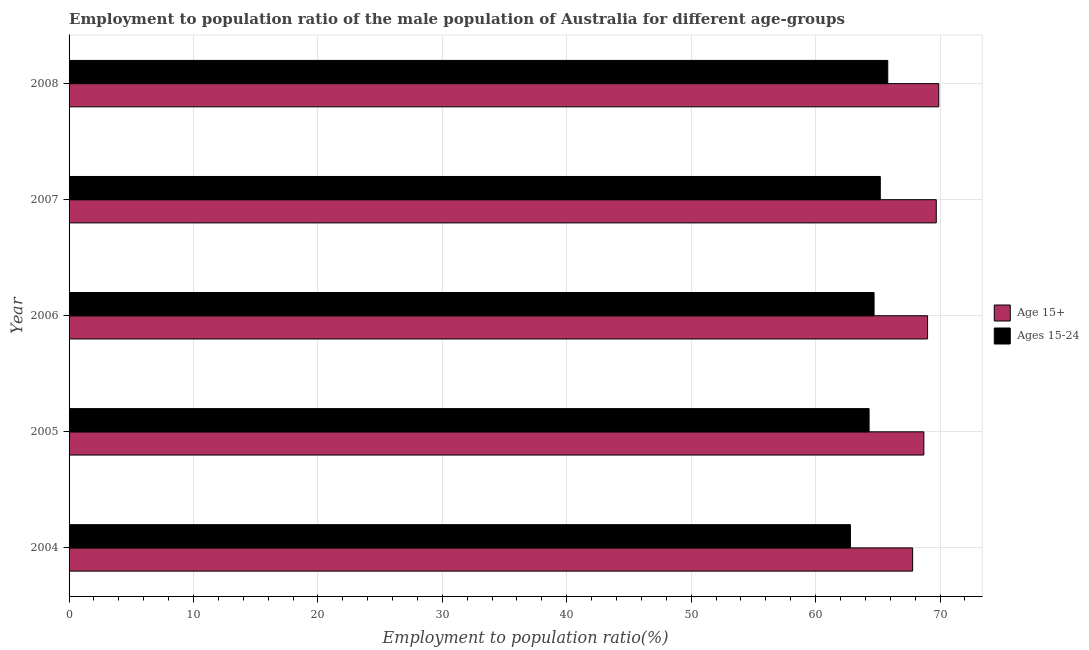Are the number of bars per tick equal to the number of legend labels?
Offer a very short reply. Yes. How many bars are there on the 1st tick from the bottom?
Offer a terse response. 2. What is the label of the 2nd group of bars from the top?
Provide a short and direct response. 2007. What is the employment to population ratio(age 15-24) in 2007?
Offer a very short reply. 65.2. Across all years, what is the maximum employment to population ratio(age 15+)?
Provide a succinct answer. 69.9. Across all years, what is the minimum employment to population ratio(age 15+)?
Offer a terse response. 67.8. In which year was the employment to population ratio(age 15-24) maximum?
Offer a terse response. 2008. In which year was the employment to population ratio(age 15-24) minimum?
Your answer should be compact. 2004. What is the total employment to population ratio(age 15-24) in the graph?
Offer a terse response. 322.8. What is the average employment to population ratio(age 15-24) per year?
Keep it short and to the point. 64.56. What is the ratio of the employment to population ratio(age 15+) in 2004 to that in 2005?
Your answer should be very brief. 0.99. Is the employment to population ratio(age 15+) in 2004 less than that in 2006?
Provide a short and direct response. Yes. Is the difference between the employment to population ratio(age 15-24) in 2004 and 2006 greater than the difference between the employment to population ratio(age 15+) in 2004 and 2006?
Make the answer very short. No. What does the 1st bar from the top in 2005 represents?
Your answer should be very brief. Ages 15-24. What does the 1st bar from the bottom in 2007 represents?
Offer a very short reply. Age 15+. Are all the bars in the graph horizontal?
Your answer should be very brief. Yes. How many years are there in the graph?
Provide a short and direct response. 5. What is the difference between two consecutive major ticks on the X-axis?
Provide a short and direct response. 10. Are the values on the major ticks of X-axis written in scientific E-notation?
Your answer should be compact. No. Does the graph contain any zero values?
Make the answer very short. No. Where does the legend appear in the graph?
Ensure brevity in your answer.  Center right. How many legend labels are there?
Ensure brevity in your answer.  2. How are the legend labels stacked?
Offer a very short reply. Vertical. What is the title of the graph?
Keep it short and to the point. Employment to population ratio of the male population of Australia for different age-groups. What is the Employment to population ratio(%) in Age 15+ in 2004?
Give a very brief answer. 67.8. What is the Employment to population ratio(%) of Ages 15-24 in 2004?
Your response must be concise. 62.8. What is the Employment to population ratio(%) in Age 15+ in 2005?
Ensure brevity in your answer.  68.7. What is the Employment to population ratio(%) of Ages 15-24 in 2005?
Ensure brevity in your answer.  64.3. What is the Employment to population ratio(%) of Age 15+ in 2006?
Your answer should be compact. 69. What is the Employment to population ratio(%) of Ages 15-24 in 2006?
Keep it short and to the point. 64.7. What is the Employment to population ratio(%) in Age 15+ in 2007?
Make the answer very short. 69.7. What is the Employment to population ratio(%) in Ages 15-24 in 2007?
Provide a succinct answer. 65.2. What is the Employment to population ratio(%) of Age 15+ in 2008?
Provide a succinct answer. 69.9. What is the Employment to population ratio(%) of Ages 15-24 in 2008?
Provide a succinct answer. 65.8. Across all years, what is the maximum Employment to population ratio(%) of Age 15+?
Your response must be concise. 69.9. Across all years, what is the maximum Employment to population ratio(%) in Ages 15-24?
Your answer should be very brief. 65.8. Across all years, what is the minimum Employment to population ratio(%) of Age 15+?
Your answer should be very brief. 67.8. Across all years, what is the minimum Employment to population ratio(%) of Ages 15-24?
Provide a succinct answer. 62.8. What is the total Employment to population ratio(%) of Age 15+ in the graph?
Ensure brevity in your answer.  345.1. What is the total Employment to population ratio(%) in Ages 15-24 in the graph?
Give a very brief answer. 322.8. What is the difference between the Employment to population ratio(%) of Age 15+ in 2004 and that in 2005?
Make the answer very short. -0.9. What is the difference between the Employment to population ratio(%) in Ages 15-24 in 2004 and that in 2005?
Your answer should be very brief. -1.5. What is the difference between the Employment to population ratio(%) of Age 15+ in 2004 and that in 2008?
Provide a succinct answer. -2.1. What is the difference between the Employment to population ratio(%) of Age 15+ in 2005 and that in 2008?
Provide a succinct answer. -1.2. What is the difference between the Employment to population ratio(%) of Age 15+ in 2006 and that in 2007?
Provide a succinct answer. -0.7. What is the difference between the Employment to population ratio(%) in Ages 15-24 in 2006 and that in 2007?
Ensure brevity in your answer.  -0.5. What is the difference between the Employment to population ratio(%) in Age 15+ in 2006 and that in 2008?
Make the answer very short. -0.9. What is the difference between the Employment to population ratio(%) of Age 15+ in 2007 and that in 2008?
Your answer should be compact. -0.2. What is the difference between the Employment to population ratio(%) of Ages 15-24 in 2007 and that in 2008?
Keep it short and to the point. -0.6. What is the difference between the Employment to population ratio(%) in Age 15+ in 2004 and the Employment to population ratio(%) in Ages 15-24 in 2005?
Keep it short and to the point. 3.5. What is the difference between the Employment to population ratio(%) in Age 15+ in 2004 and the Employment to population ratio(%) in Ages 15-24 in 2008?
Offer a terse response. 2. What is the difference between the Employment to population ratio(%) of Age 15+ in 2005 and the Employment to population ratio(%) of Ages 15-24 in 2007?
Provide a succinct answer. 3.5. What is the average Employment to population ratio(%) of Age 15+ per year?
Offer a terse response. 69.02. What is the average Employment to population ratio(%) in Ages 15-24 per year?
Your response must be concise. 64.56. In the year 2004, what is the difference between the Employment to population ratio(%) of Age 15+ and Employment to population ratio(%) of Ages 15-24?
Your response must be concise. 5. In the year 2005, what is the difference between the Employment to population ratio(%) of Age 15+ and Employment to population ratio(%) of Ages 15-24?
Keep it short and to the point. 4.4. In the year 2007, what is the difference between the Employment to population ratio(%) in Age 15+ and Employment to population ratio(%) in Ages 15-24?
Give a very brief answer. 4.5. In the year 2008, what is the difference between the Employment to population ratio(%) in Age 15+ and Employment to population ratio(%) in Ages 15-24?
Provide a short and direct response. 4.1. What is the ratio of the Employment to population ratio(%) of Age 15+ in 2004 to that in 2005?
Ensure brevity in your answer.  0.99. What is the ratio of the Employment to population ratio(%) of Ages 15-24 in 2004 to that in 2005?
Provide a succinct answer. 0.98. What is the ratio of the Employment to population ratio(%) of Age 15+ in 2004 to that in 2006?
Offer a terse response. 0.98. What is the ratio of the Employment to population ratio(%) in Ages 15-24 in 2004 to that in 2006?
Give a very brief answer. 0.97. What is the ratio of the Employment to population ratio(%) of Age 15+ in 2004 to that in 2007?
Your answer should be compact. 0.97. What is the ratio of the Employment to population ratio(%) of Ages 15-24 in 2004 to that in 2007?
Provide a succinct answer. 0.96. What is the ratio of the Employment to population ratio(%) of Age 15+ in 2004 to that in 2008?
Your answer should be very brief. 0.97. What is the ratio of the Employment to population ratio(%) in Ages 15-24 in 2004 to that in 2008?
Offer a terse response. 0.95. What is the ratio of the Employment to population ratio(%) of Age 15+ in 2005 to that in 2007?
Your answer should be very brief. 0.99. What is the ratio of the Employment to population ratio(%) in Ages 15-24 in 2005 to that in 2007?
Provide a succinct answer. 0.99. What is the ratio of the Employment to population ratio(%) of Age 15+ in 2005 to that in 2008?
Provide a short and direct response. 0.98. What is the ratio of the Employment to population ratio(%) in Ages 15-24 in 2005 to that in 2008?
Make the answer very short. 0.98. What is the ratio of the Employment to population ratio(%) in Age 15+ in 2006 to that in 2008?
Provide a succinct answer. 0.99. What is the ratio of the Employment to population ratio(%) in Ages 15-24 in 2006 to that in 2008?
Give a very brief answer. 0.98. What is the ratio of the Employment to population ratio(%) in Age 15+ in 2007 to that in 2008?
Your response must be concise. 1. What is the ratio of the Employment to population ratio(%) in Ages 15-24 in 2007 to that in 2008?
Your response must be concise. 0.99. What is the difference between the highest and the second highest Employment to population ratio(%) in Age 15+?
Ensure brevity in your answer.  0.2. What is the difference between the highest and the second highest Employment to population ratio(%) of Ages 15-24?
Your answer should be very brief. 0.6. What is the difference between the highest and the lowest Employment to population ratio(%) in Ages 15-24?
Your answer should be very brief. 3. 